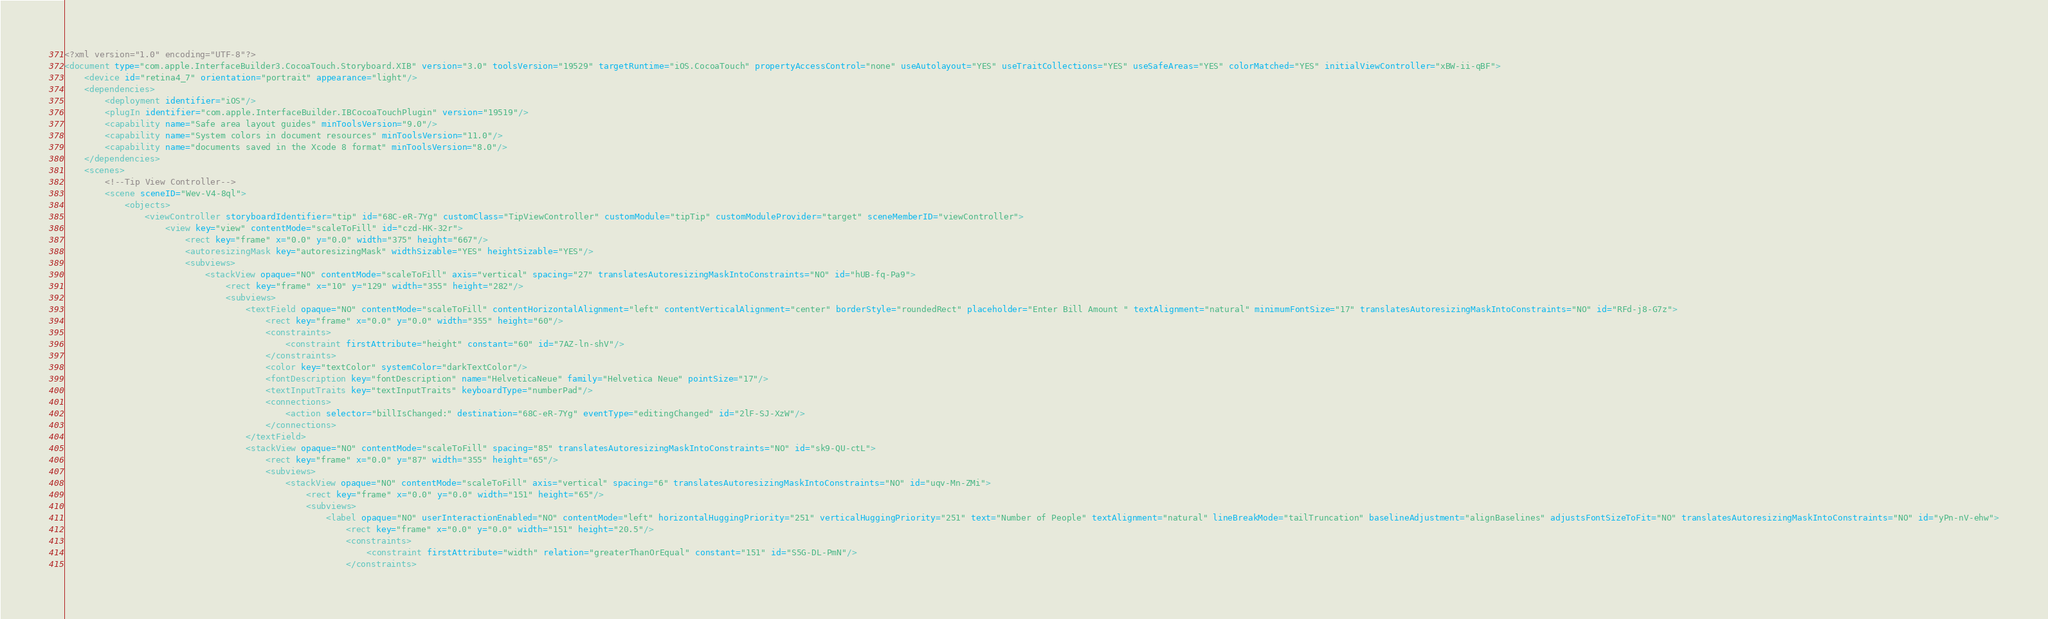Convert code to text. <code><loc_0><loc_0><loc_500><loc_500><_XML_><?xml version="1.0" encoding="UTF-8"?>
<document type="com.apple.InterfaceBuilder3.CocoaTouch.Storyboard.XIB" version="3.0" toolsVersion="19529" targetRuntime="iOS.CocoaTouch" propertyAccessControl="none" useAutolayout="YES" useTraitCollections="YES" useSafeAreas="YES" colorMatched="YES" initialViewController="xBW-ii-qBF">
    <device id="retina4_7" orientation="portrait" appearance="light"/>
    <dependencies>
        <deployment identifier="iOS"/>
        <plugIn identifier="com.apple.InterfaceBuilder.IBCocoaTouchPlugin" version="19519"/>
        <capability name="Safe area layout guides" minToolsVersion="9.0"/>
        <capability name="System colors in document resources" minToolsVersion="11.0"/>
        <capability name="documents saved in the Xcode 8 format" minToolsVersion="8.0"/>
    </dependencies>
    <scenes>
        <!--Tip View Controller-->
        <scene sceneID="Wev-V4-8ql">
            <objects>
                <viewController storyboardIdentifier="tip" id="68C-eR-7Yg" customClass="TipViewController" customModule="tipTip" customModuleProvider="target" sceneMemberID="viewController">
                    <view key="view" contentMode="scaleToFill" id="czd-HK-32r">
                        <rect key="frame" x="0.0" y="0.0" width="375" height="667"/>
                        <autoresizingMask key="autoresizingMask" widthSizable="YES" heightSizable="YES"/>
                        <subviews>
                            <stackView opaque="NO" contentMode="scaleToFill" axis="vertical" spacing="27" translatesAutoresizingMaskIntoConstraints="NO" id="hUB-fq-Pa9">
                                <rect key="frame" x="10" y="129" width="355" height="282"/>
                                <subviews>
                                    <textField opaque="NO" contentMode="scaleToFill" contentHorizontalAlignment="left" contentVerticalAlignment="center" borderStyle="roundedRect" placeholder="Enter Bill Amount " textAlignment="natural" minimumFontSize="17" translatesAutoresizingMaskIntoConstraints="NO" id="RFd-j8-G7z">
                                        <rect key="frame" x="0.0" y="0.0" width="355" height="60"/>
                                        <constraints>
                                            <constraint firstAttribute="height" constant="60" id="7AZ-ln-shV"/>
                                        </constraints>
                                        <color key="textColor" systemColor="darkTextColor"/>
                                        <fontDescription key="fontDescription" name="HelveticaNeue" family="Helvetica Neue" pointSize="17"/>
                                        <textInputTraits key="textInputTraits" keyboardType="numberPad"/>
                                        <connections>
                                            <action selector="billIsChanged:" destination="68C-eR-7Yg" eventType="editingChanged" id="2lF-SJ-XzW"/>
                                        </connections>
                                    </textField>
                                    <stackView opaque="NO" contentMode="scaleToFill" spacing="85" translatesAutoresizingMaskIntoConstraints="NO" id="sk9-QU-ctL">
                                        <rect key="frame" x="0.0" y="87" width="355" height="65"/>
                                        <subviews>
                                            <stackView opaque="NO" contentMode="scaleToFill" axis="vertical" spacing="6" translatesAutoresizingMaskIntoConstraints="NO" id="uqv-Mn-ZMi">
                                                <rect key="frame" x="0.0" y="0.0" width="151" height="65"/>
                                                <subviews>
                                                    <label opaque="NO" userInteractionEnabled="NO" contentMode="left" horizontalHuggingPriority="251" verticalHuggingPriority="251" text="Number of People" textAlignment="natural" lineBreakMode="tailTruncation" baselineAdjustment="alignBaselines" adjustsFontSizeToFit="NO" translatesAutoresizingMaskIntoConstraints="NO" id="yPn-nV-ehw">
                                                        <rect key="frame" x="0.0" y="0.0" width="151" height="20.5"/>
                                                        <constraints>
                                                            <constraint firstAttribute="width" relation="greaterThanOrEqual" constant="151" id="S5G-DL-PmN"/>
                                                        </constraints></code> 